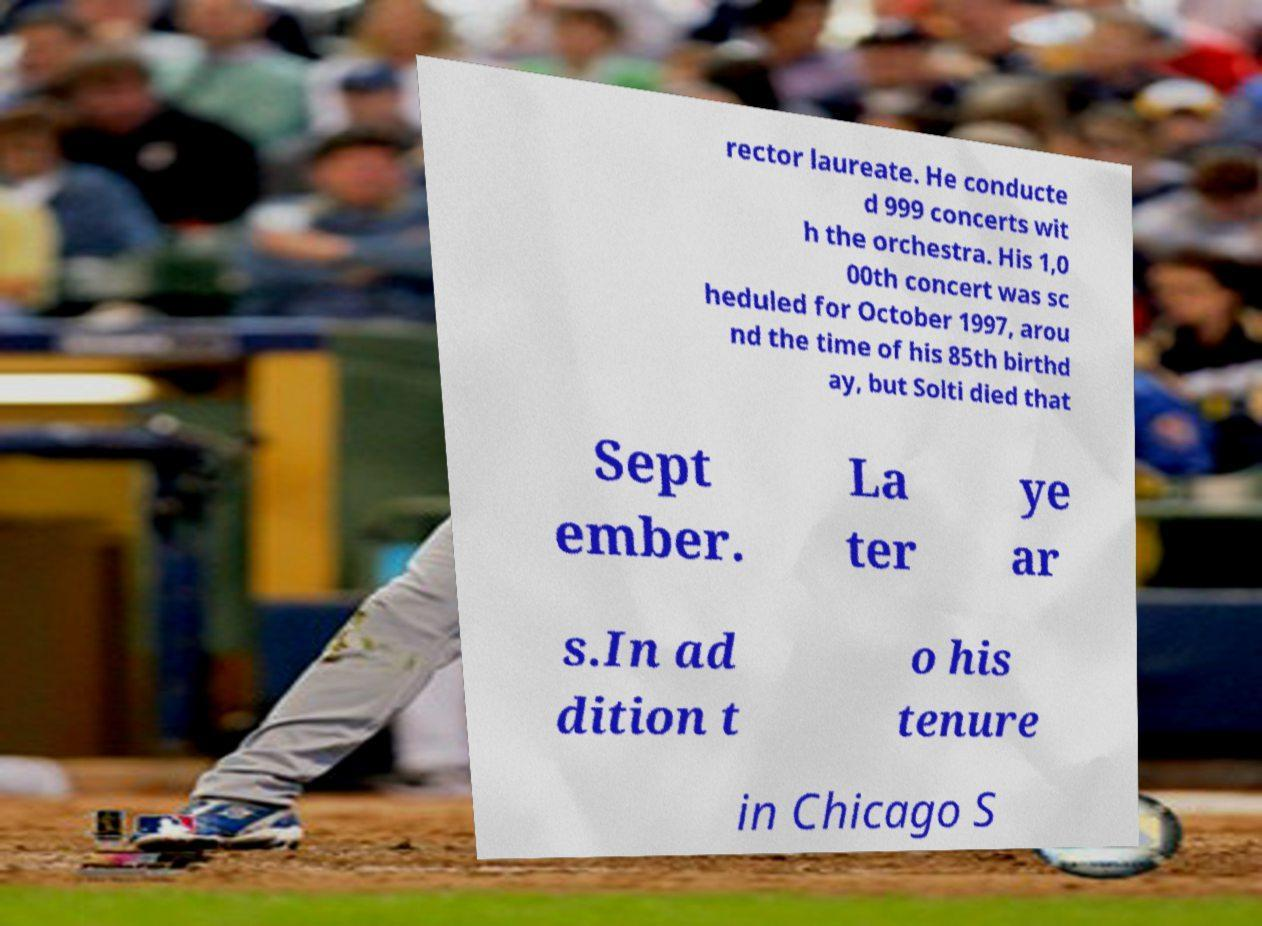What messages or text are displayed in this image? I need them in a readable, typed format. rector laureate. He conducte d 999 concerts wit h the orchestra. His 1,0 00th concert was sc heduled for October 1997, arou nd the time of his 85th birthd ay, but Solti died that Sept ember. La ter ye ar s.In ad dition t o his tenure in Chicago S 